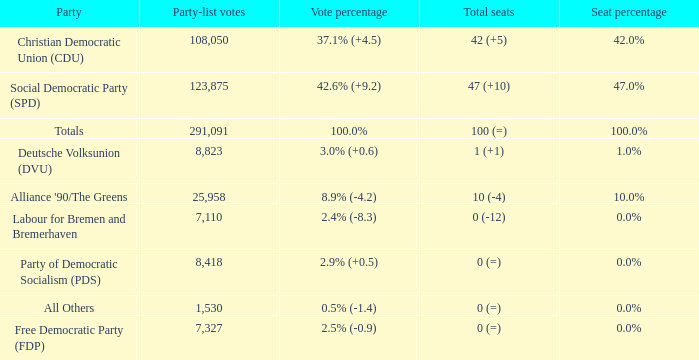Could you parse the entire table? {'header': ['Party', 'Party-list votes', 'Vote percentage', 'Total seats', 'Seat percentage'], 'rows': [['Christian Democratic Union (CDU)', '108,050', '37.1% (+4.5)', '42 (+5)', '42.0%'], ['Social Democratic Party (SPD)', '123,875', '42.6% (+9.2)', '47 (+10)', '47.0%'], ['Totals', '291,091', '100.0%', '100 (=)', '100.0%'], ['Deutsche Volksunion (DVU)', '8,823', '3.0% (+0.6)', '1 (+1)', '1.0%'], ["Alliance '90/The Greens", '25,958', '8.9% (-4.2)', '10 (-4)', '10.0%'], ['Labour for Bremen and Bremerhaven', '7,110', '2.4% (-8.3)', '0 (-12)', '0.0%'], ['Party of Democratic Socialism (PDS)', '8,418', '2.9% (+0.5)', '0 (=)', '0.0%'], ['All Others', '1,530', '0.5% (-1.4)', '0 (=)', '0.0%'], ['Free Democratic Party (FDP)', '7,327', '2.5% (-0.9)', '0 (=)', '0.0%']]} What is the seat percentage when vote percentage is 2.4% (-8.3)? 0.0%. 